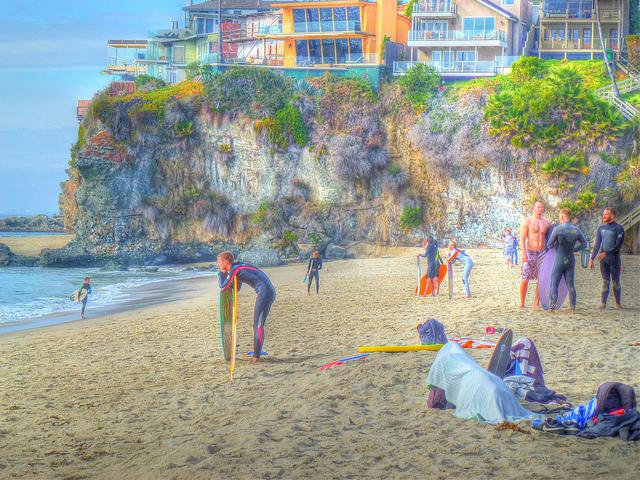Where are the people?
Keep it brief. Beach. Is this an inland location?
Quick response, please. No. What is the purpose of the blue object?
Write a very short answer. Surfing. Is this a real photo?
Be succinct. No. 